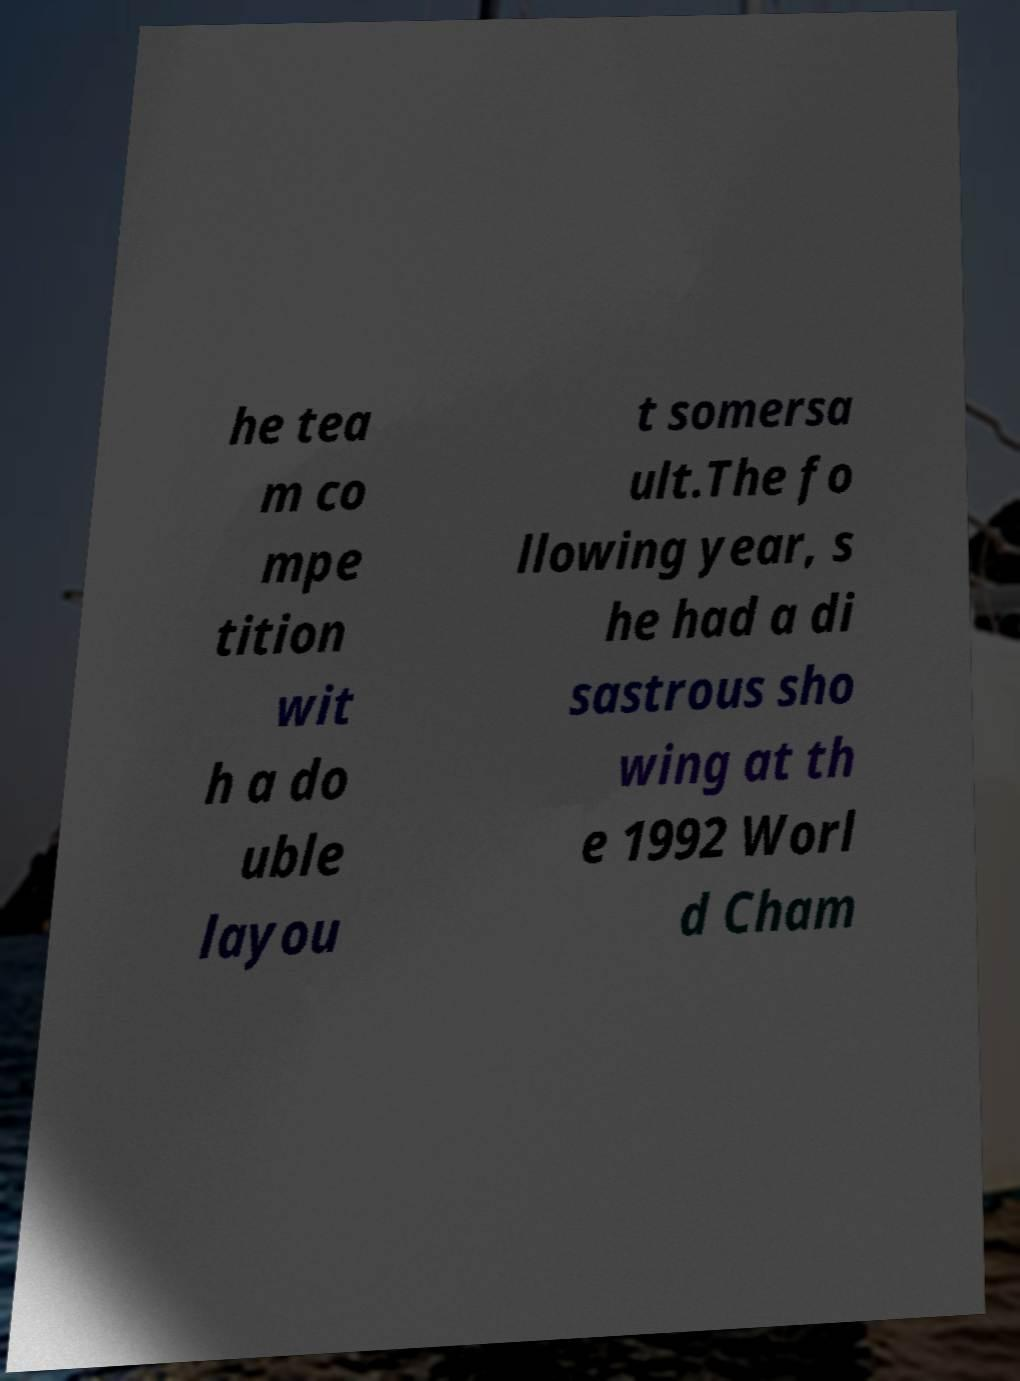Could you extract and type out the text from this image? he tea m co mpe tition wit h a do uble layou t somersa ult.The fo llowing year, s he had a di sastrous sho wing at th e 1992 Worl d Cham 